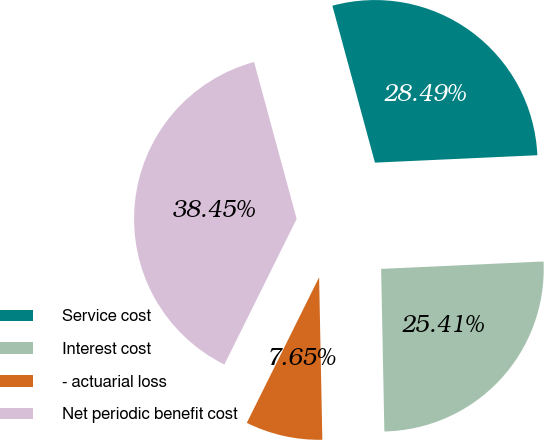<chart> <loc_0><loc_0><loc_500><loc_500><pie_chart><fcel>Service cost<fcel>Interest cost<fcel>- actuarial loss<fcel>Net periodic benefit cost<nl><fcel>28.49%<fcel>25.41%<fcel>7.65%<fcel>38.45%<nl></chart> 